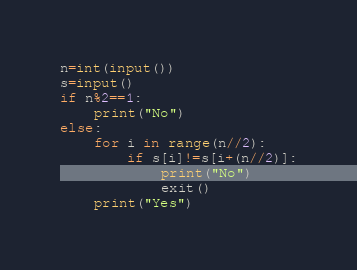Convert code to text. <code><loc_0><loc_0><loc_500><loc_500><_Python_>n=int(input())
s=input()
if n%2==1:
    print("No")
else:
    for i in range(n//2):
        if s[i]!=s[i+(n//2)]:
            print("No")
            exit()
    print("Yes")

</code> 